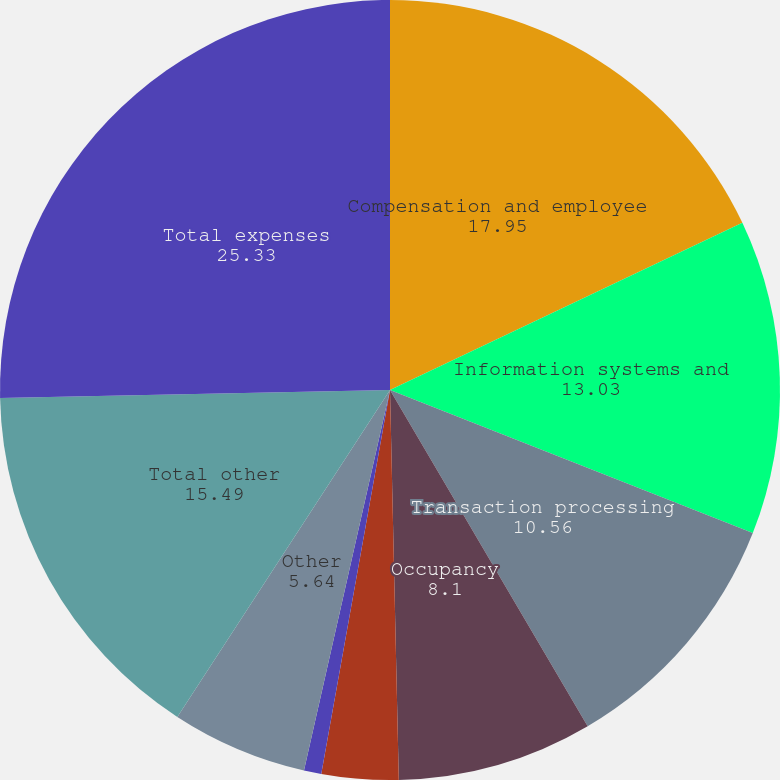Convert chart to OTSL. <chart><loc_0><loc_0><loc_500><loc_500><pie_chart><fcel>Compensation and employee<fcel>Information systems and<fcel>Transaction processing<fcel>Occupancy<fcel>Professional services<fcel>Amortization of other<fcel>Other<fcel>Total other<fcel>Total expenses<nl><fcel>17.95%<fcel>13.03%<fcel>10.56%<fcel>8.1%<fcel>3.18%<fcel>0.72%<fcel>5.64%<fcel>15.49%<fcel>25.33%<nl></chart> 